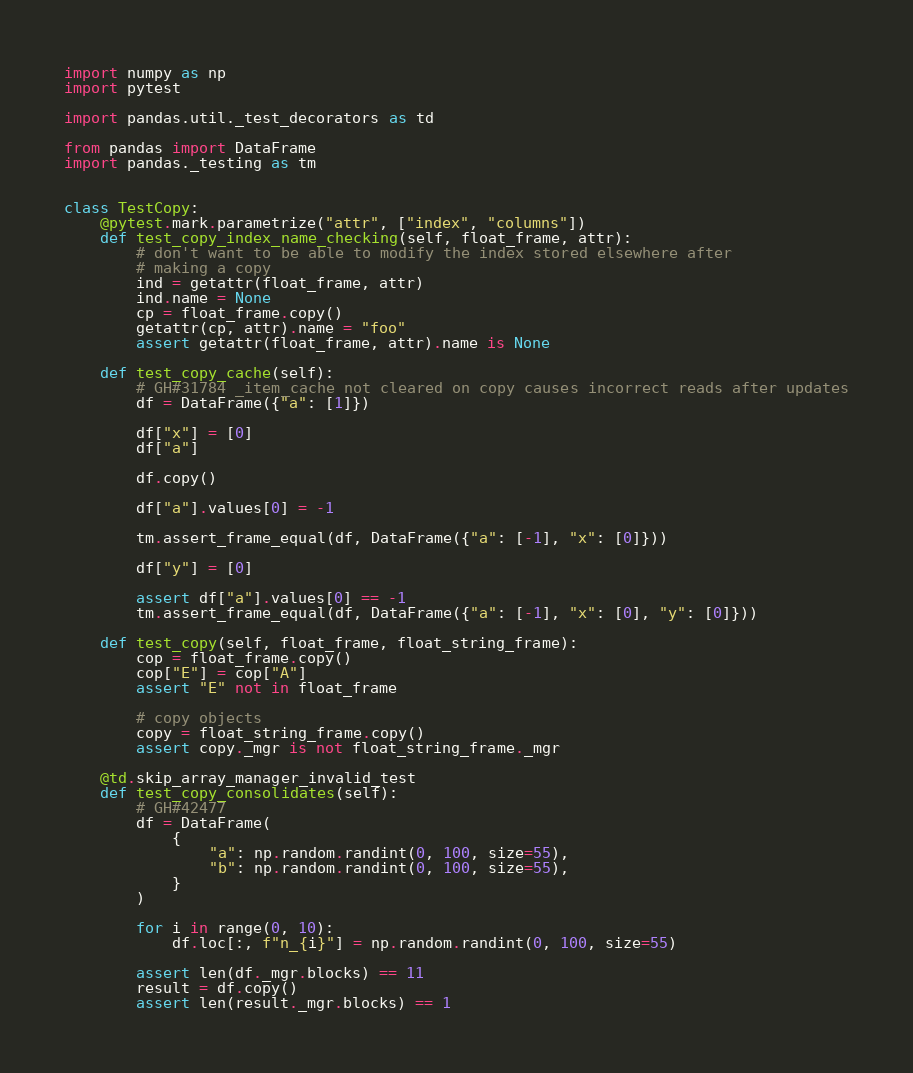<code> <loc_0><loc_0><loc_500><loc_500><_Python_>import numpy as np
import pytest

import pandas.util._test_decorators as td

from pandas import DataFrame
import pandas._testing as tm


class TestCopy:
    @pytest.mark.parametrize("attr", ["index", "columns"])
    def test_copy_index_name_checking(self, float_frame, attr):
        # don't want to be able to modify the index stored elsewhere after
        # making a copy
        ind = getattr(float_frame, attr)
        ind.name = None
        cp = float_frame.copy()
        getattr(cp, attr).name = "foo"
        assert getattr(float_frame, attr).name is None

    def test_copy_cache(self):
        # GH#31784 _item_cache not cleared on copy causes incorrect reads after updates
        df = DataFrame({"a": [1]})

        df["x"] = [0]
        df["a"]

        df.copy()

        df["a"].values[0] = -1

        tm.assert_frame_equal(df, DataFrame({"a": [-1], "x": [0]}))

        df["y"] = [0]

        assert df["a"].values[0] == -1
        tm.assert_frame_equal(df, DataFrame({"a": [-1], "x": [0], "y": [0]}))

    def test_copy(self, float_frame, float_string_frame):
        cop = float_frame.copy()
        cop["E"] = cop["A"]
        assert "E" not in float_frame

        # copy objects
        copy = float_string_frame.copy()
        assert copy._mgr is not float_string_frame._mgr

    @td.skip_array_manager_invalid_test
    def test_copy_consolidates(self):
        # GH#42477
        df = DataFrame(
            {
                "a": np.random.randint(0, 100, size=55),
                "b": np.random.randint(0, 100, size=55),
            }
        )

        for i in range(0, 10):
            df.loc[:, f"n_{i}"] = np.random.randint(0, 100, size=55)

        assert len(df._mgr.blocks) == 11
        result = df.copy()
        assert len(result._mgr.blocks) == 1
</code> 